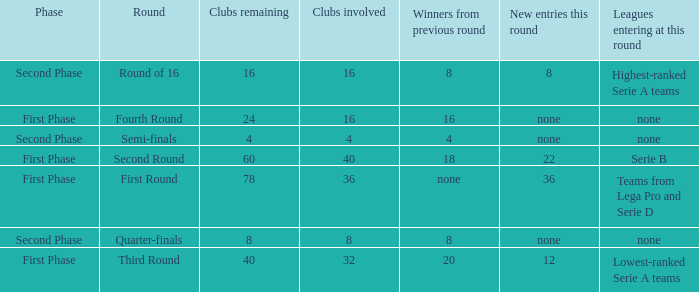Clubs involved is 8, what number would you find from winners from previous round? 8.0. 